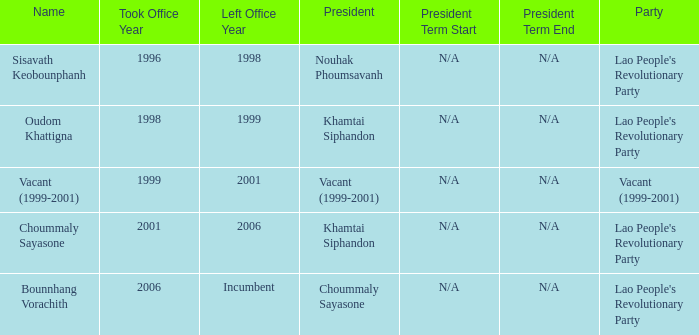What is Name, when President is Khamtai Siphandon, and when Left Office is 1999? Oudom Khattigna. 